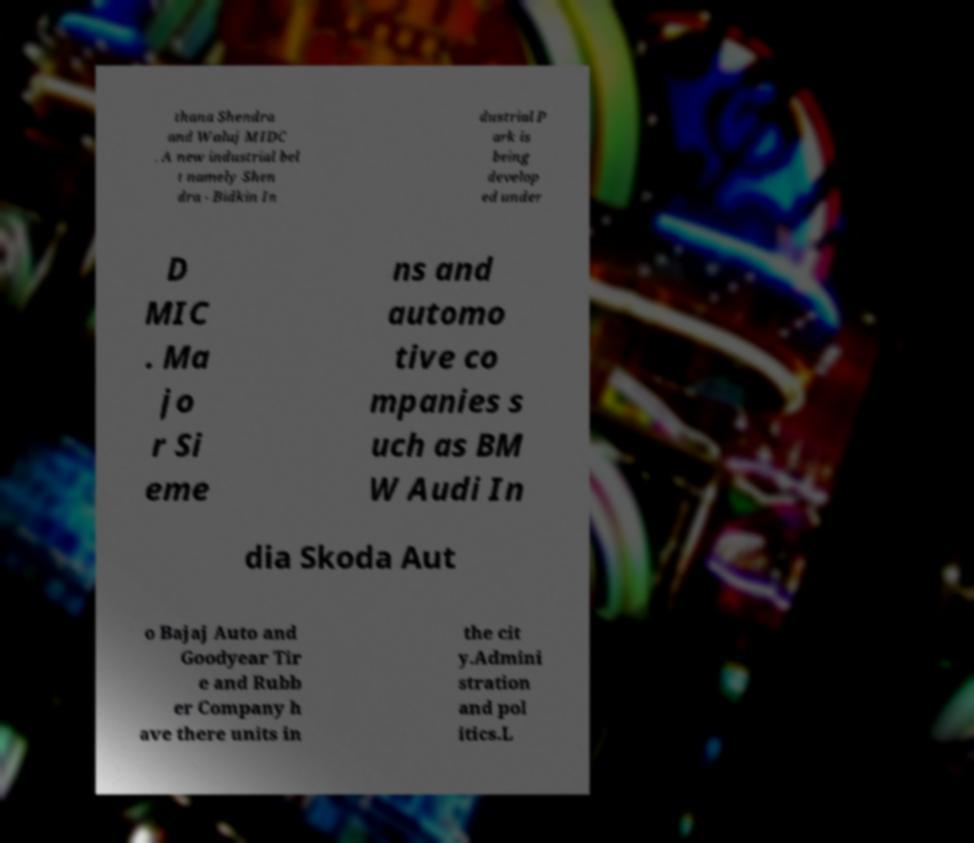I need the written content from this picture converted into text. Can you do that? thana Shendra and Waluj MIDC . A new industrial bel t namely Shen dra - Bidkin In dustrial P ark is being develop ed under D MIC . Ma jo r Si eme ns and automo tive co mpanies s uch as BM W Audi In dia Skoda Aut o Bajaj Auto and Goodyear Tir e and Rubb er Company h ave there units in the cit y.Admini stration and pol itics.L 